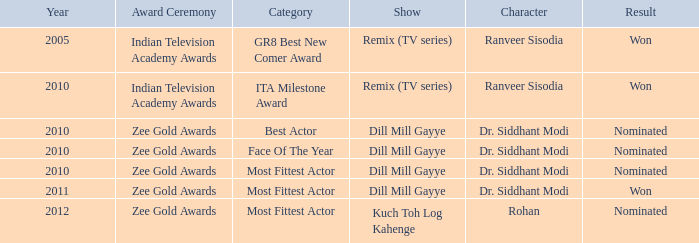Which program features a character named rohan? Kuch Toh Log Kahenge. 